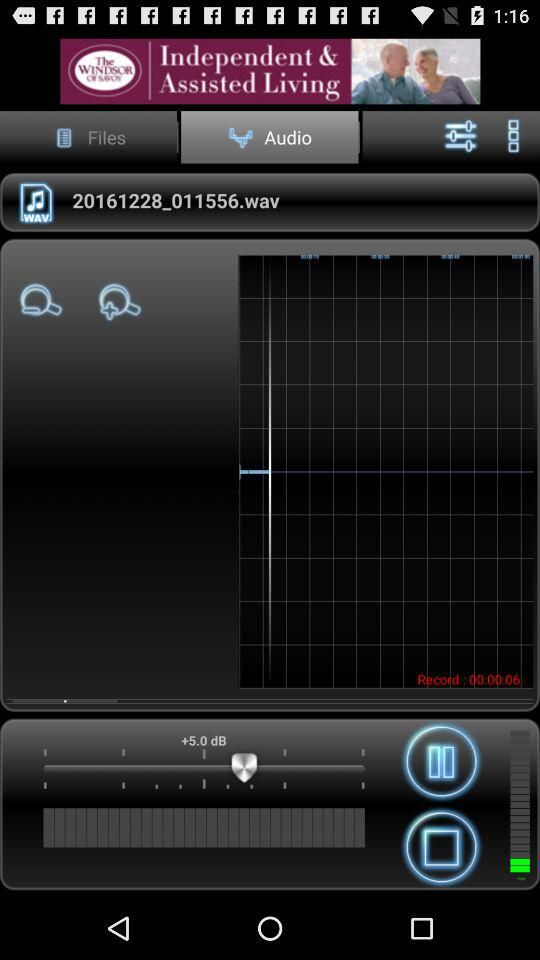How many seconds has the recording been going for?
Answer the question using a single word or phrase. 6 